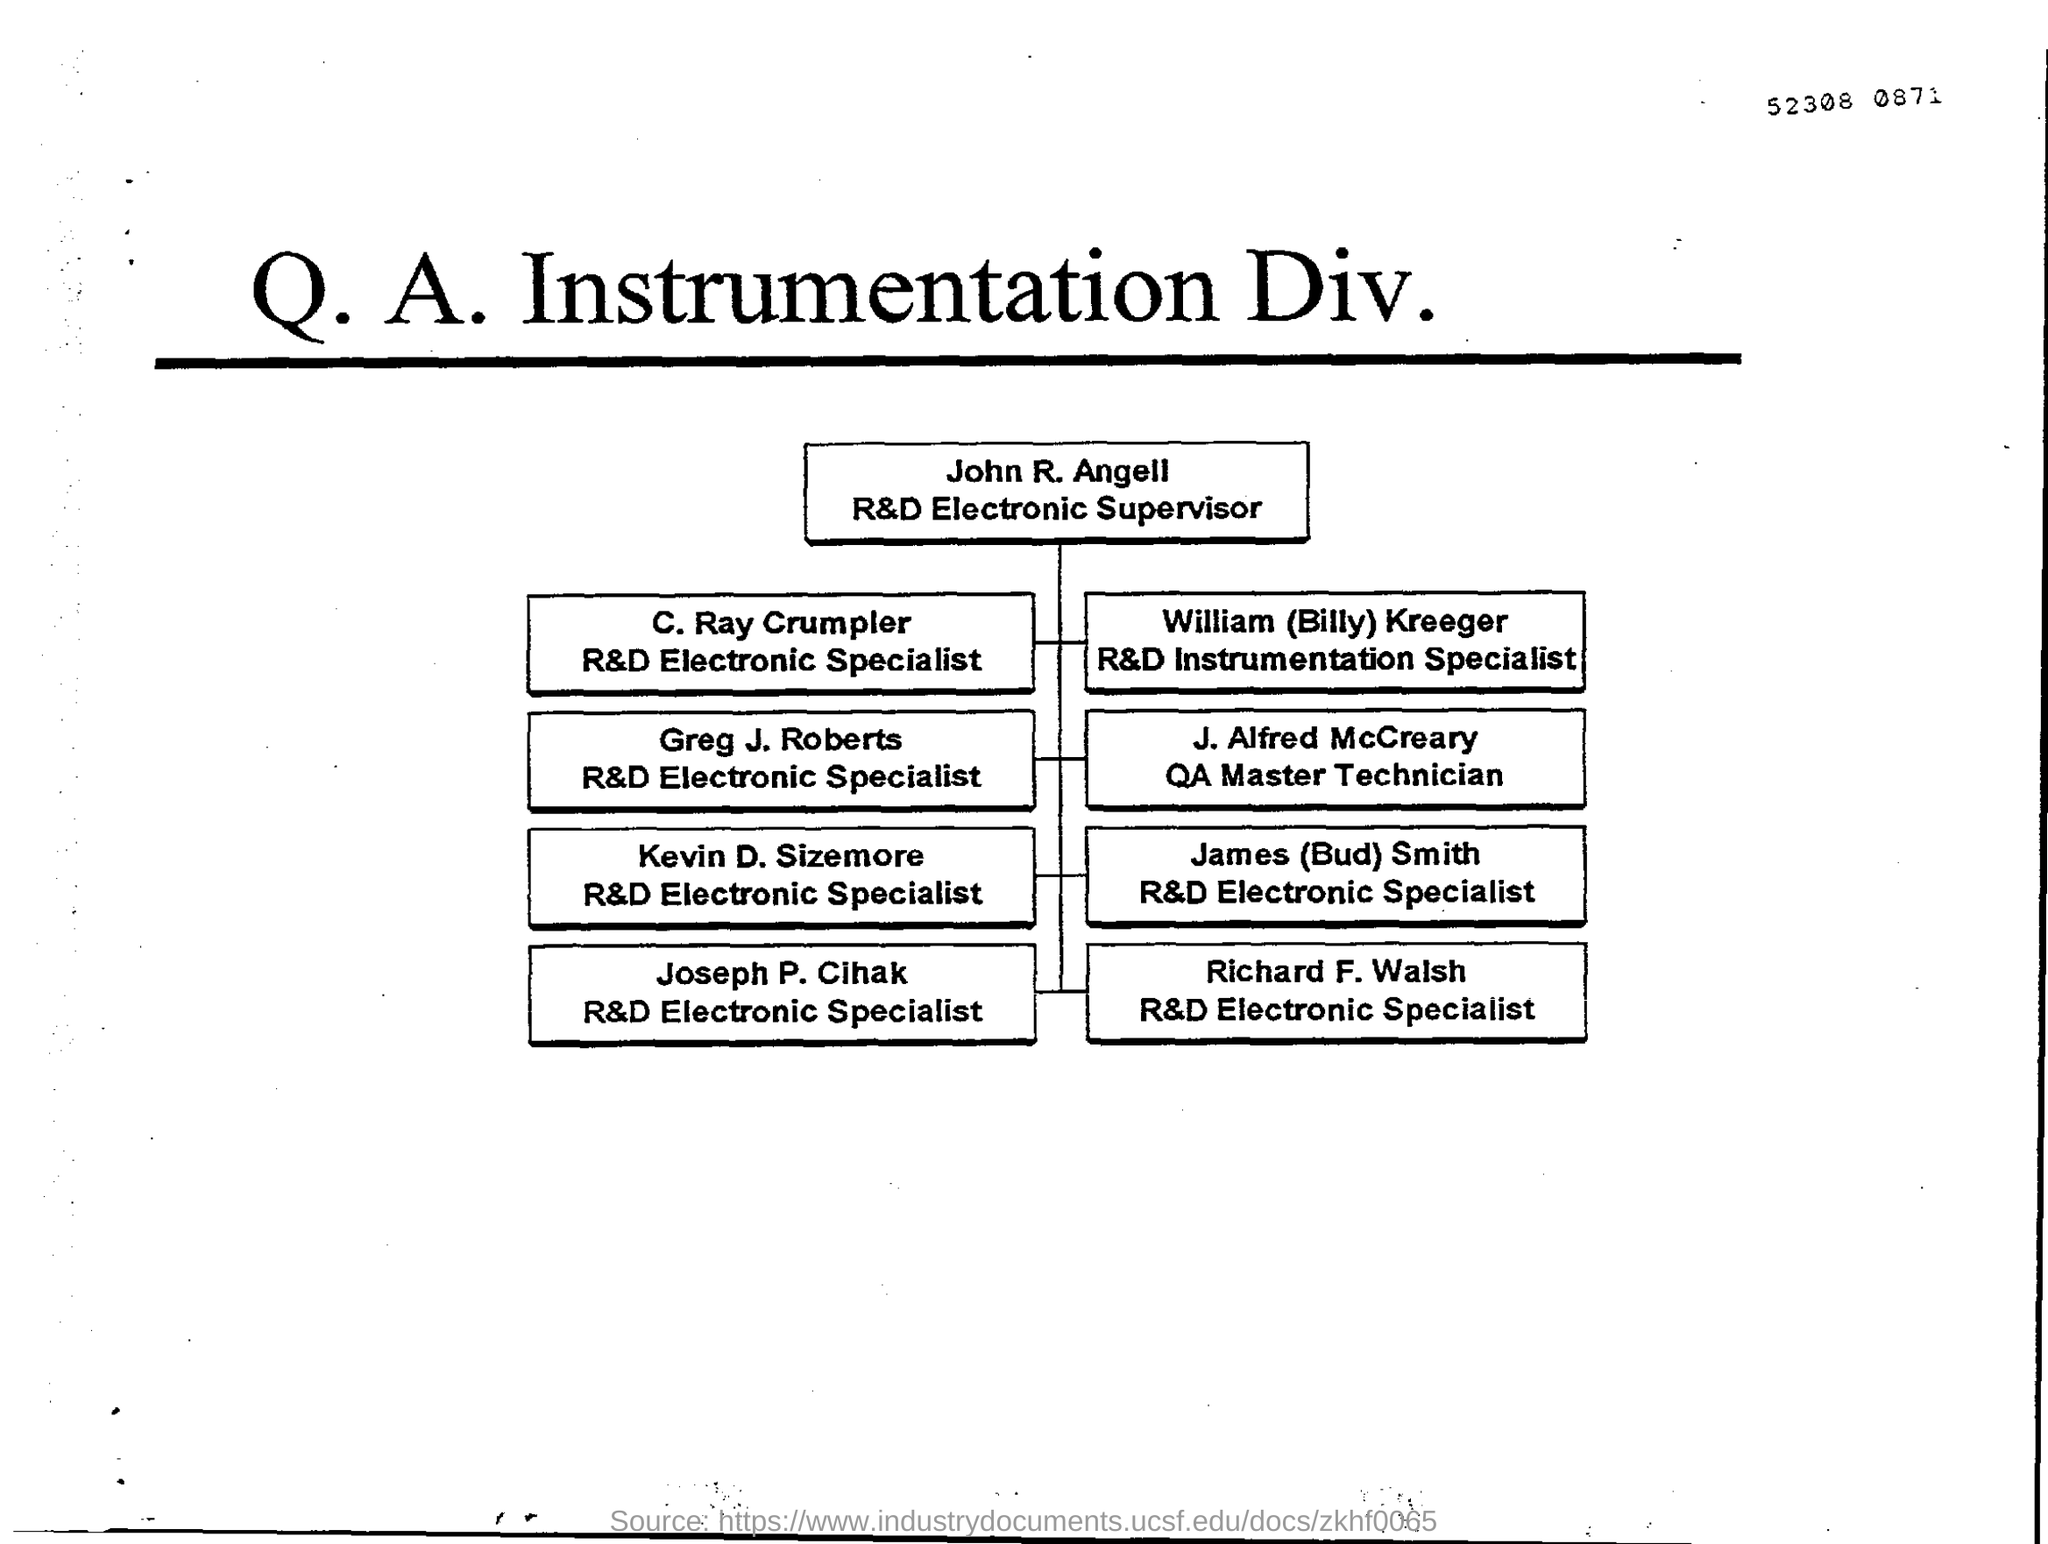Who is the R&D Electronic Supervisor?
Provide a short and direct response. John R. Angell. 